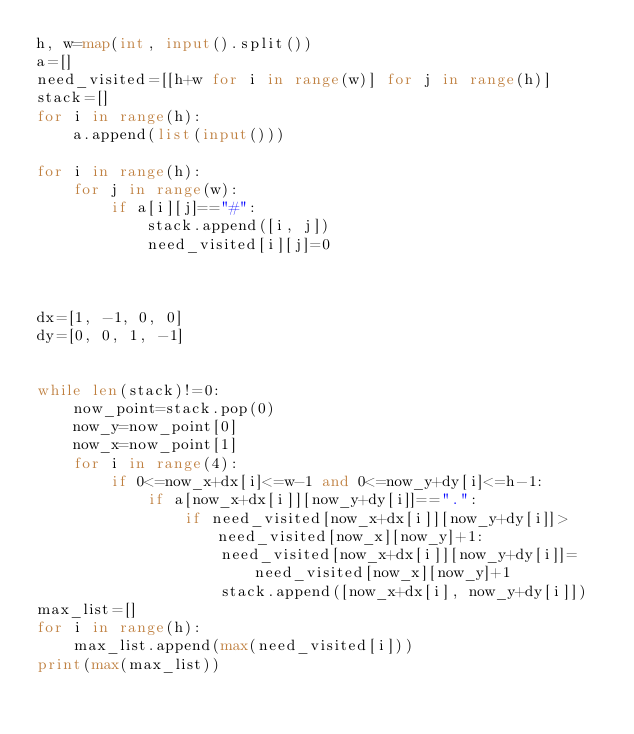<code> <loc_0><loc_0><loc_500><loc_500><_Python_>h, w=map(int, input().split())
a=[]
need_visited=[[h+w for i in range(w)] for j in range(h)]
stack=[]
for i in range(h):
    a.append(list(input()))

for i in range(h):
    for j in range(w):
        if a[i][j]=="#":
            stack.append([i, j])
            need_visited[i][j]=0



dx=[1, -1, 0, 0]
dy=[0, 0, 1, -1]


while len(stack)!=0:
    now_point=stack.pop(0)
    now_y=now_point[0]
    now_x=now_point[1]
    for i in range(4):
        if 0<=now_x+dx[i]<=w-1 and 0<=now_y+dy[i]<=h-1:
            if a[now_x+dx[i]][now_y+dy[i]]==".":
                if need_visited[now_x+dx[i]][now_y+dy[i]]>need_visited[now_x][now_y]+1:
                    need_visited[now_x+dx[i]][now_y+dy[i]]=need_visited[now_x][now_y]+1
                    stack.append([now_x+dx[i], now_y+dy[i]])
max_list=[]
for i in range(h):
    max_list.append(max(need_visited[i]))
print(max(max_list))
</code> 